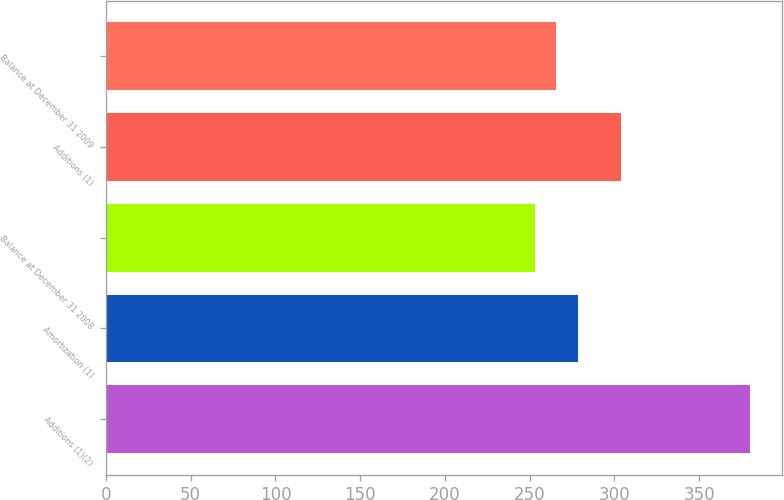<chart> <loc_0><loc_0><loc_500><loc_500><bar_chart><fcel>Additions (1)(2)<fcel>Amortization (1)<fcel>Balance at December 31 2008<fcel>Additions (1)<fcel>Balance at December 31 2009<nl><fcel>380<fcel>278.4<fcel>253<fcel>304<fcel>265.7<nl></chart> 